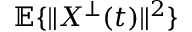<formula> <loc_0><loc_0><loc_500><loc_500>\mathbb { E } \{ \| X ^ { \bot } ( t ) \| ^ { 2 } \}</formula> 